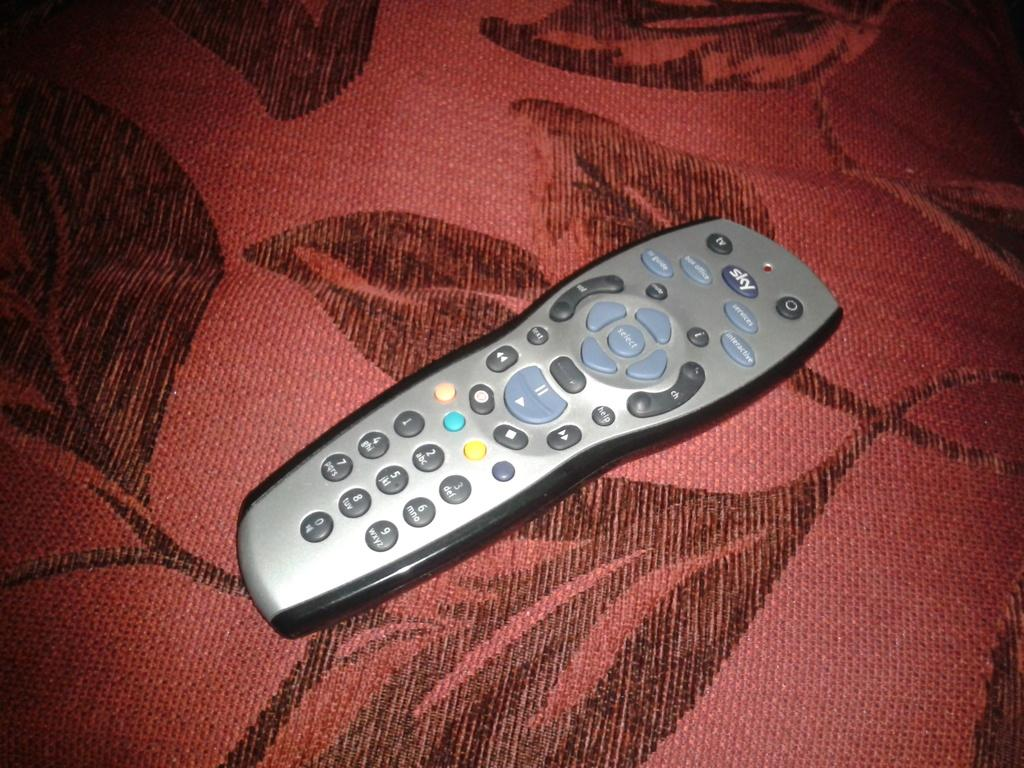<image>
Present a compact description of the photo's key features. A SKY remote control with a TV button and a Select button, lays on a cloth that is red with black leaves.. 